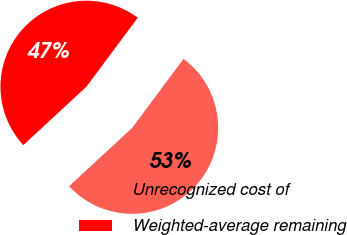Convert chart. <chart><loc_0><loc_0><loc_500><loc_500><pie_chart><fcel>Unrecognized cost of<fcel>Weighted-average remaining<nl><fcel>52.94%<fcel>47.06%<nl></chart> 